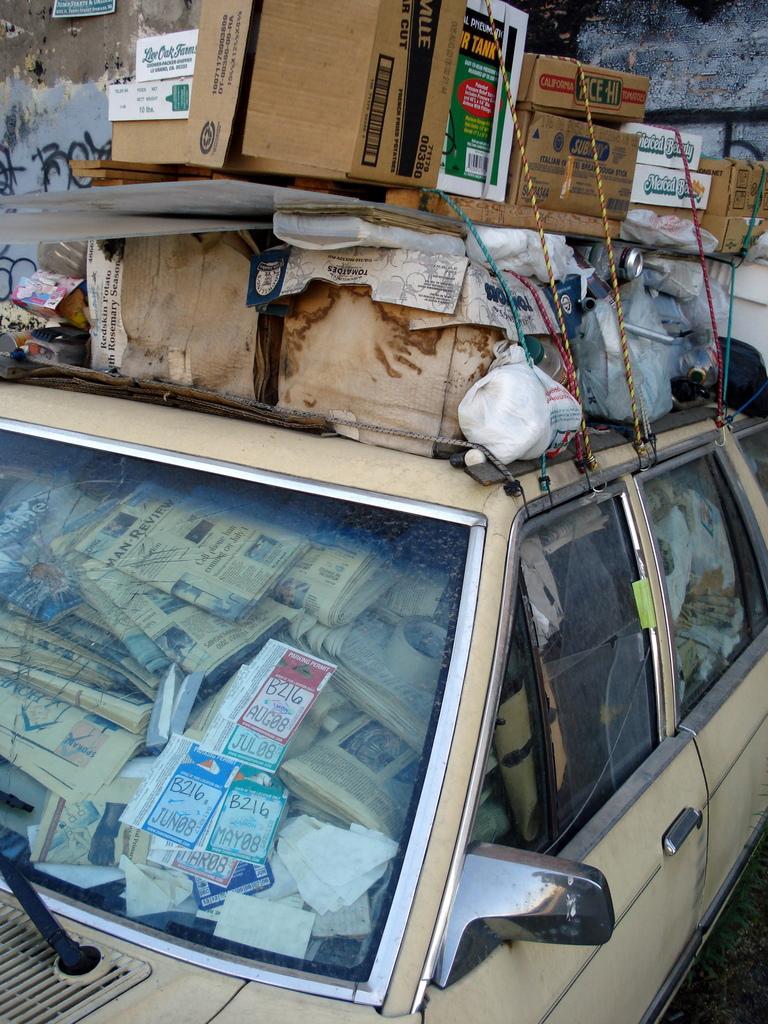Could you give a brief overview of what you see in this image? In this picture we can see there are newspapers in a vehicle. At the top of the vehicle there are cardboard boxes and some objects. Behind the cardboard boxes there is the wall with a board. 